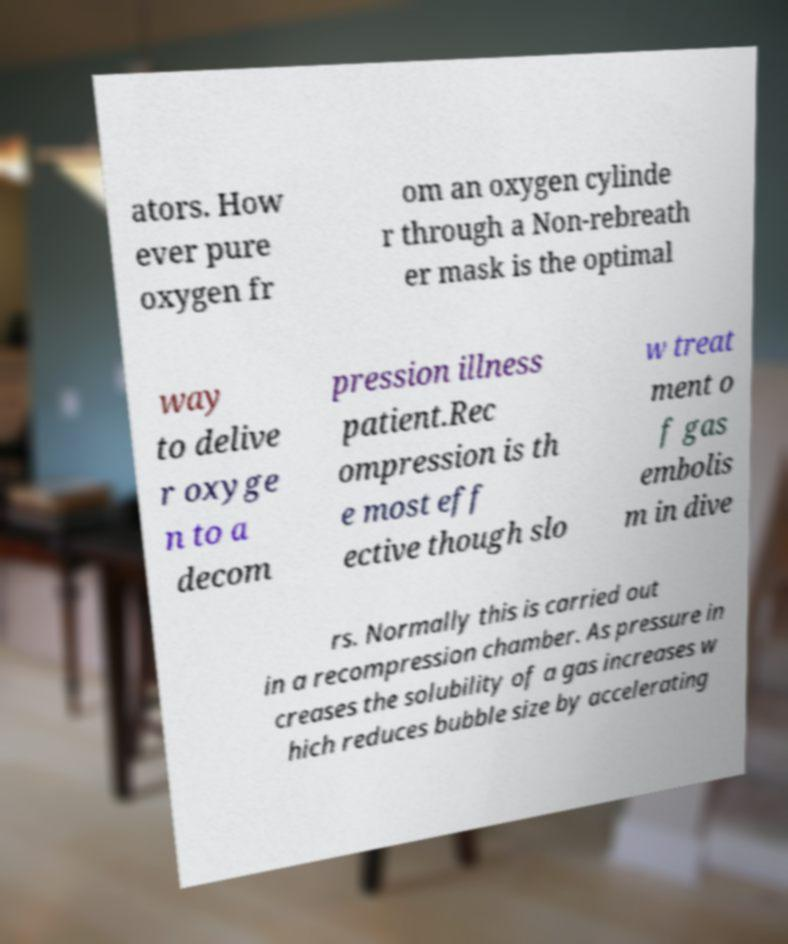Can you accurately transcribe the text from the provided image for me? ators. How ever pure oxygen fr om an oxygen cylinde r through a Non-rebreath er mask is the optimal way to delive r oxyge n to a decom pression illness patient.Rec ompression is th e most eff ective though slo w treat ment o f gas embolis m in dive rs. Normally this is carried out in a recompression chamber. As pressure in creases the solubility of a gas increases w hich reduces bubble size by accelerating 